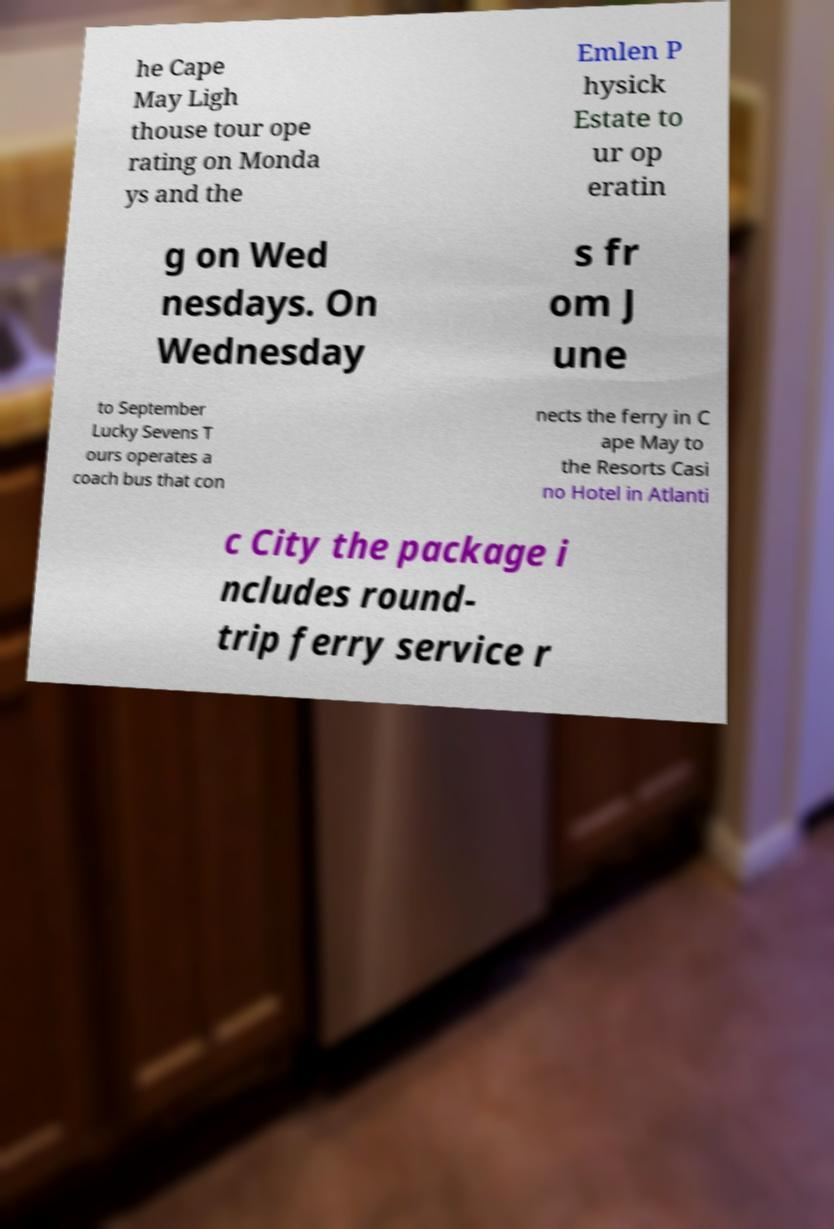What messages or text are displayed in this image? I need them in a readable, typed format. he Cape May Ligh thouse tour ope rating on Monda ys and the Emlen P hysick Estate to ur op eratin g on Wed nesdays. On Wednesday s fr om J une to September Lucky Sevens T ours operates a coach bus that con nects the ferry in C ape May to the Resorts Casi no Hotel in Atlanti c City the package i ncludes round- trip ferry service r 